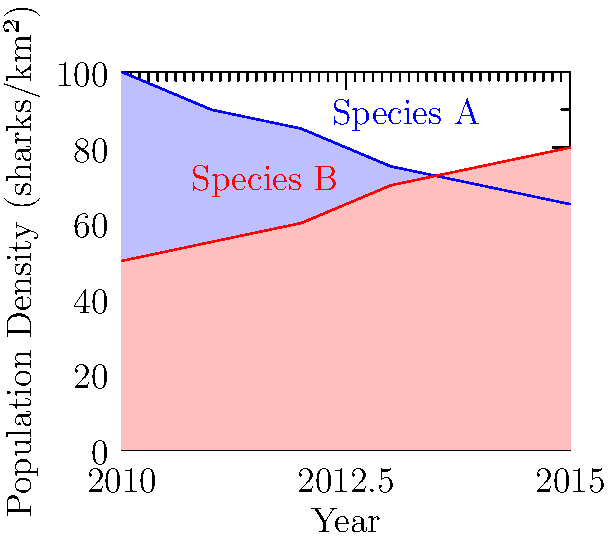The area chart shows the population density changes for two shark species (A and B) from 2010 to 2015. In which year did the population densities of the two species become approximately equal? To determine when the population densities of Species A and B became approximately equal, we need to follow these steps:

1. Analyze the trends:
   - Species A (blue) shows a decreasing trend
   - Species B (red) shows an increasing trend

2. Look for an intersection point:
   The point where the two lines cross or come very close together indicates when the population densities are approximately equal.

3. Identify the year:
   By examining the graph, we can see that the lines for Species A and B intersect around 2013.

4. Verify the values:
   At 2013, both species have a population density of approximately 75 sharks/km².

5. Check surrounding years:
   - In 2012, Species A has a higher density than Species B
   - In 2014, Species B has a higher density than Species A
   This confirms that 2013 is the year when the densities became approximately equal.
Answer: 2013 